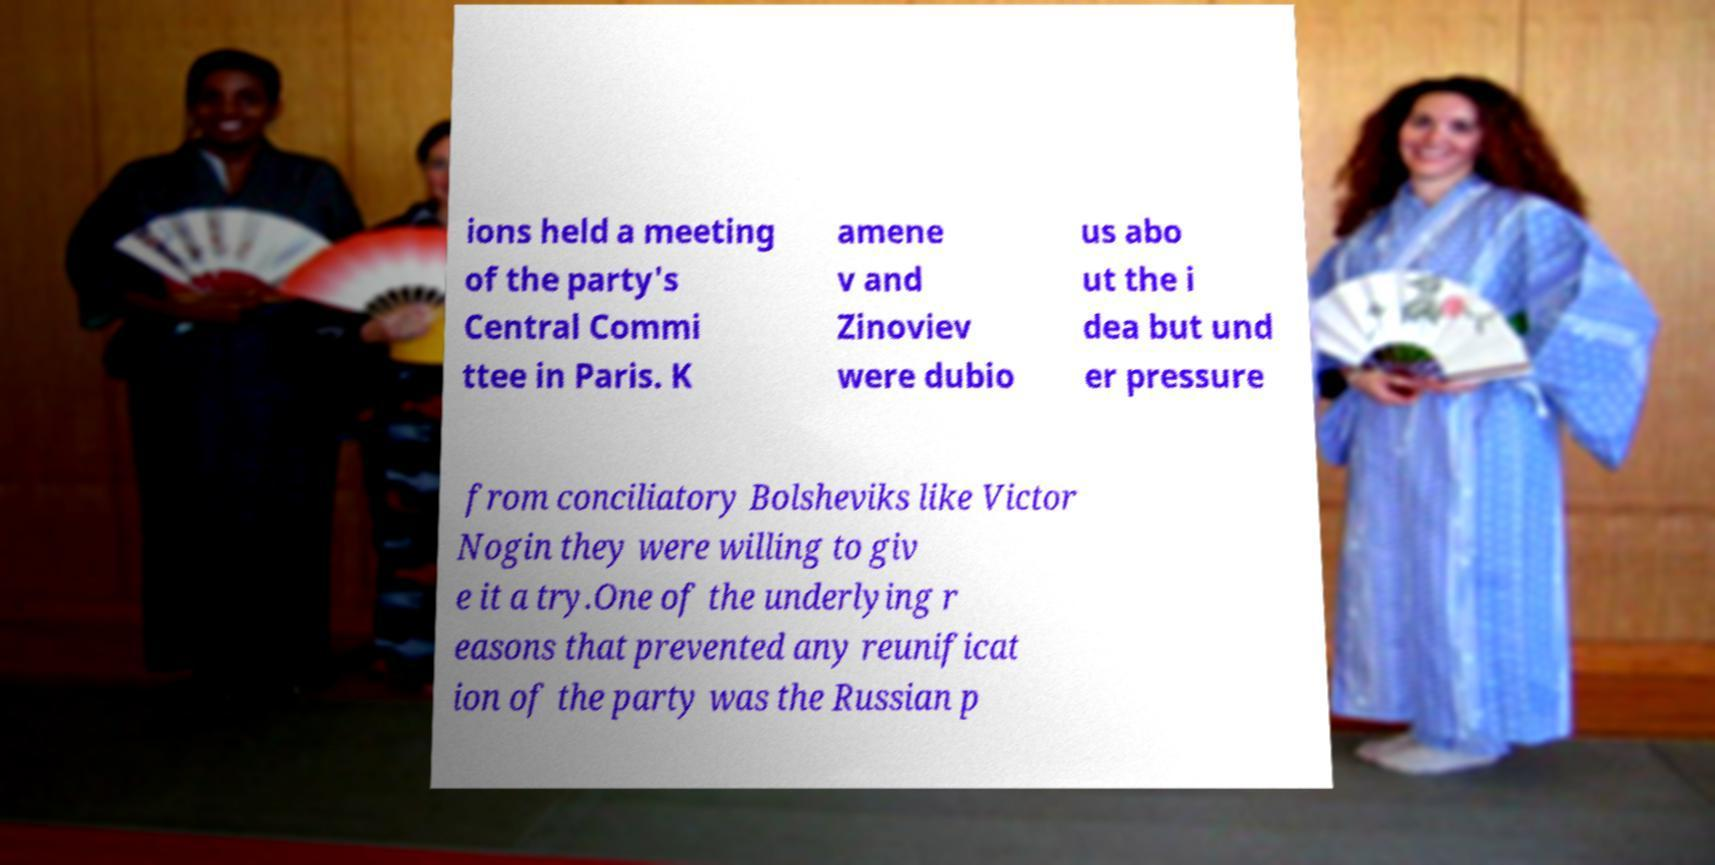What messages or text are displayed in this image? I need them in a readable, typed format. ions held a meeting of the party's Central Commi ttee in Paris. K amene v and Zinoviev were dubio us abo ut the i dea but und er pressure from conciliatory Bolsheviks like Victor Nogin they were willing to giv e it a try.One of the underlying r easons that prevented any reunificat ion of the party was the Russian p 